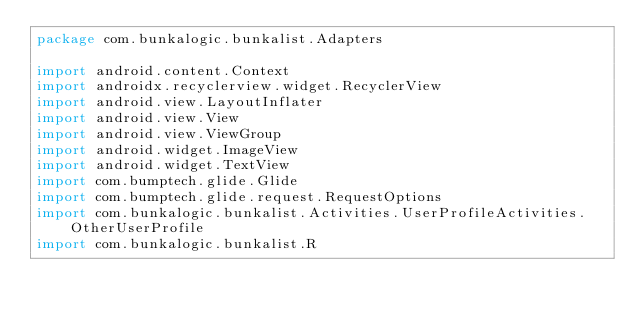<code> <loc_0><loc_0><loc_500><loc_500><_Kotlin_>package com.bunkalogic.bunkalist.Adapters

import android.content.Context
import androidx.recyclerview.widget.RecyclerView
import android.view.LayoutInflater
import android.view.View
import android.view.ViewGroup
import android.widget.ImageView
import android.widget.TextView
import com.bumptech.glide.Glide
import com.bumptech.glide.request.RequestOptions
import com.bunkalogic.bunkalist.Activities.UserProfileActivities.OtherUserProfile
import com.bunkalogic.bunkalist.R</code> 